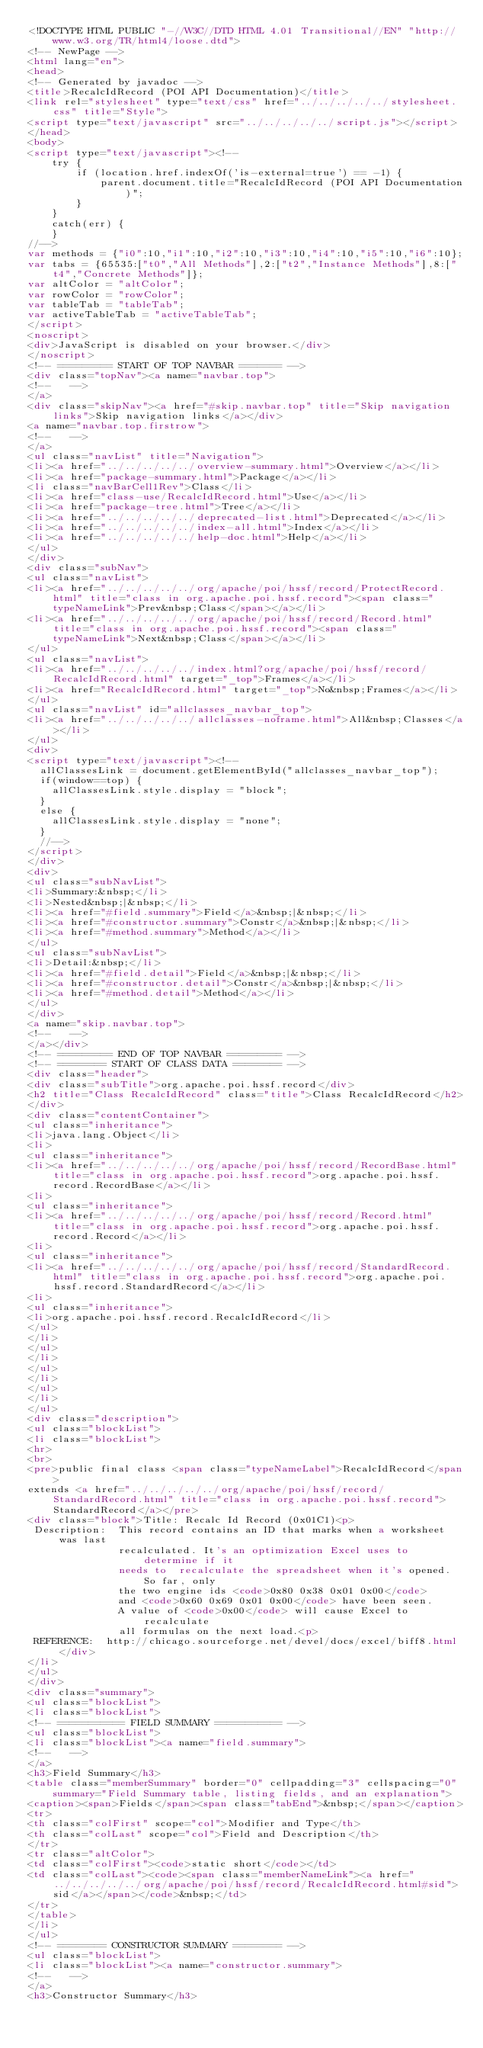Convert code to text. <code><loc_0><loc_0><loc_500><loc_500><_HTML_><!DOCTYPE HTML PUBLIC "-//W3C//DTD HTML 4.01 Transitional//EN" "http://www.w3.org/TR/html4/loose.dtd">
<!-- NewPage -->
<html lang="en">
<head>
<!-- Generated by javadoc -->
<title>RecalcIdRecord (POI API Documentation)</title>
<link rel="stylesheet" type="text/css" href="../../../../../stylesheet.css" title="Style">
<script type="text/javascript" src="../../../../../script.js"></script>
</head>
<body>
<script type="text/javascript"><!--
    try {
        if (location.href.indexOf('is-external=true') == -1) {
            parent.document.title="RecalcIdRecord (POI API Documentation)";
        }
    }
    catch(err) {
    }
//-->
var methods = {"i0":10,"i1":10,"i2":10,"i3":10,"i4":10,"i5":10,"i6":10};
var tabs = {65535:["t0","All Methods"],2:["t2","Instance Methods"],8:["t4","Concrete Methods"]};
var altColor = "altColor";
var rowColor = "rowColor";
var tableTab = "tableTab";
var activeTableTab = "activeTableTab";
</script>
<noscript>
<div>JavaScript is disabled on your browser.</div>
</noscript>
<!-- ========= START OF TOP NAVBAR ======= -->
<div class="topNav"><a name="navbar.top">
<!--   -->
</a>
<div class="skipNav"><a href="#skip.navbar.top" title="Skip navigation links">Skip navigation links</a></div>
<a name="navbar.top.firstrow">
<!--   -->
</a>
<ul class="navList" title="Navigation">
<li><a href="../../../../../overview-summary.html">Overview</a></li>
<li><a href="package-summary.html">Package</a></li>
<li class="navBarCell1Rev">Class</li>
<li><a href="class-use/RecalcIdRecord.html">Use</a></li>
<li><a href="package-tree.html">Tree</a></li>
<li><a href="../../../../../deprecated-list.html">Deprecated</a></li>
<li><a href="../../../../../index-all.html">Index</a></li>
<li><a href="../../../../../help-doc.html">Help</a></li>
</ul>
</div>
<div class="subNav">
<ul class="navList">
<li><a href="../../../../../org/apache/poi/hssf/record/ProtectRecord.html" title="class in org.apache.poi.hssf.record"><span class="typeNameLink">Prev&nbsp;Class</span></a></li>
<li><a href="../../../../../org/apache/poi/hssf/record/Record.html" title="class in org.apache.poi.hssf.record"><span class="typeNameLink">Next&nbsp;Class</span></a></li>
</ul>
<ul class="navList">
<li><a href="../../../../../index.html?org/apache/poi/hssf/record/RecalcIdRecord.html" target="_top">Frames</a></li>
<li><a href="RecalcIdRecord.html" target="_top">No&nbsp;Frames</a></li>
</ul>
<ul class="navList" id="allclasses_navbar_top">
<li><a href="../../../../../allclasses-noframe.html">All&nbsp;Classes</a></li>
</ul>
<div>
<script type="text/javascript"><!--
  allClassesLink = document.getElementById("allclasses_navbar_top");
  if(window==top) {
    allClassesLink.style.display = "block";
  }
  else {
    allClassesLink.style.display = "none";
  }
  //-->
</script>
</div>
<div>
<ul class="subNavList">
<li>Summary:&nbsp;</li>
<li>Nested&nbsp;|&nbsp;</li>
<li><a href="#field.summary">Field</a>&nbsp;|&nbsp;</li>
<li><a href="#constructor.summary">Constr</a>&nbsp;|&nbsp;</li>
<li><a href="#method.summary">Method</a></li>
</ul>
<ul class="subNavList">
<li>Detail:&nbsp;</li>
<li><a href="#field.detail">Field</a>&nbsp;|&nbsp;</li>
<li><a href="#constructor.detail">Constr</a>&nbsp;|&nbsp;</li>
<li><a href="#method.detail">Method</a></li>
</ul>
</div>
<a name="skip.navbar.top">
<!--   -->
</a></div>
<!-- ========= END OF TOP NAVBAR ========= -->
<!-- ======== START OF CLASS DATA ======== -->
<div class="header">
<div class="subTitle">org.apache.poi.hssf.record</div>
<h2 title="Class RecalcIdRecord" class="title">Class RecalcIdRecord</h2>
</div>
<div class="contentContainer">
<ul class="inheritance">
<li>java.lang.Object</li>
<li>
<ul class="inheritance">
<li><a href="../../../../../org/apache/poi/hssf/record/RecordBase.html" title="class in org.apache.poi.hssf.record">org.apache.poi.hssf.record.RecordBase</a></li>
<li>
<ul class="inheritance">
<li><a href="../../../../../org/apache/poi/hssf/record/Record.html" title="class in org.apache.poi.hssf.record">org.apache.poi.hssf.record.Record</a></li>
<li>
<ul class="inheritance">
<li><a href="../../../../../org/apache/poi/hssf/record/StandardRecord.html" title="class in org.apache.poi.hssf.record">org.apache.poi.hssf.record.StandardRecord</a></li>
<li>
<ul class="inheritance">
<li>org.apache.poi.hssf.record.RecalcIdRecord</li>
</ul>
</li>
</ul>
</li>
</ul>
</li>
</ul>
</li>
</ul>
<div class="description">
<ul class="blockList">
<li class="blockList">
<hr>
<br>
<pre>public final class <span class="typeNameLabel">RecalcIdRecord</span>
extends <a href="../../../../../org/apache/poi/hssf/record/StandardRecord.html" title="class in org.apache.poi.hssf.record">StandardRecord</a></pre>
<div class="block">Title: Recalc Id Record (0x01C1)<p>
 Description:  This record contains an ID that marks when a worksheet was last
               recalculated. It's an optimization Excel uses to determine if it
               needs to  recalculate the spreadsheet when it's opened. So far, only
               the two engine ids <code>0x80 0x38 0x01 0x00</code>
               and <code>0x60 0x69 0x01 0x00</code> have been seen.
               A value of <code>0x00</code> will cause Excel to recalculate
               all formulas on the next load.<p>
 REFERENCE:  http://chicago.sourceforge.net/devel/docs/excel/biff8.html</div>
</li>
</ul>
</div>
<div class="summary">
<ul class="blockList">
<li class="blockList">
<!-- =========== FIELD SUMMARY =========== -->
<ul class="blockList">
<li class="blockList"><a name="field.summary">
<!--   -->
</a>
<h3>Field Summary</h3>
<table class="memberSummary" border="0" cellpadding="3" cellspacing="0" summary="Field Summary table, listing fields, and an explanation">
<caption><span>Fields</span><span class="tabEnd">&nbsp;</span></caption>
<tr>
<th class="colFirst" scope="col">Modifier and Type</th>
<th class="colLast" scope="col">Field and Description</th>
</tr>
<tr class="altColor">
<td class="colFirst"><code>static short</code></td>
<td class="colLast"><code><span class="memberNameLink"><a href="../../../../../org/apache/poi/hssf/record/RecalcIdRecord.html#sid">sid</a></span></code>&nbsp;</td>
</tr>
</table>
</li>
</ul>
<!-- ======== CONSTRUCTOR SUMMARY ======== -->
<ul class="blockList">
<li class="blockList"><a name="constructor.summary">
<!--   -->
</a>
<h3>Constructor Summary</h3></code> 